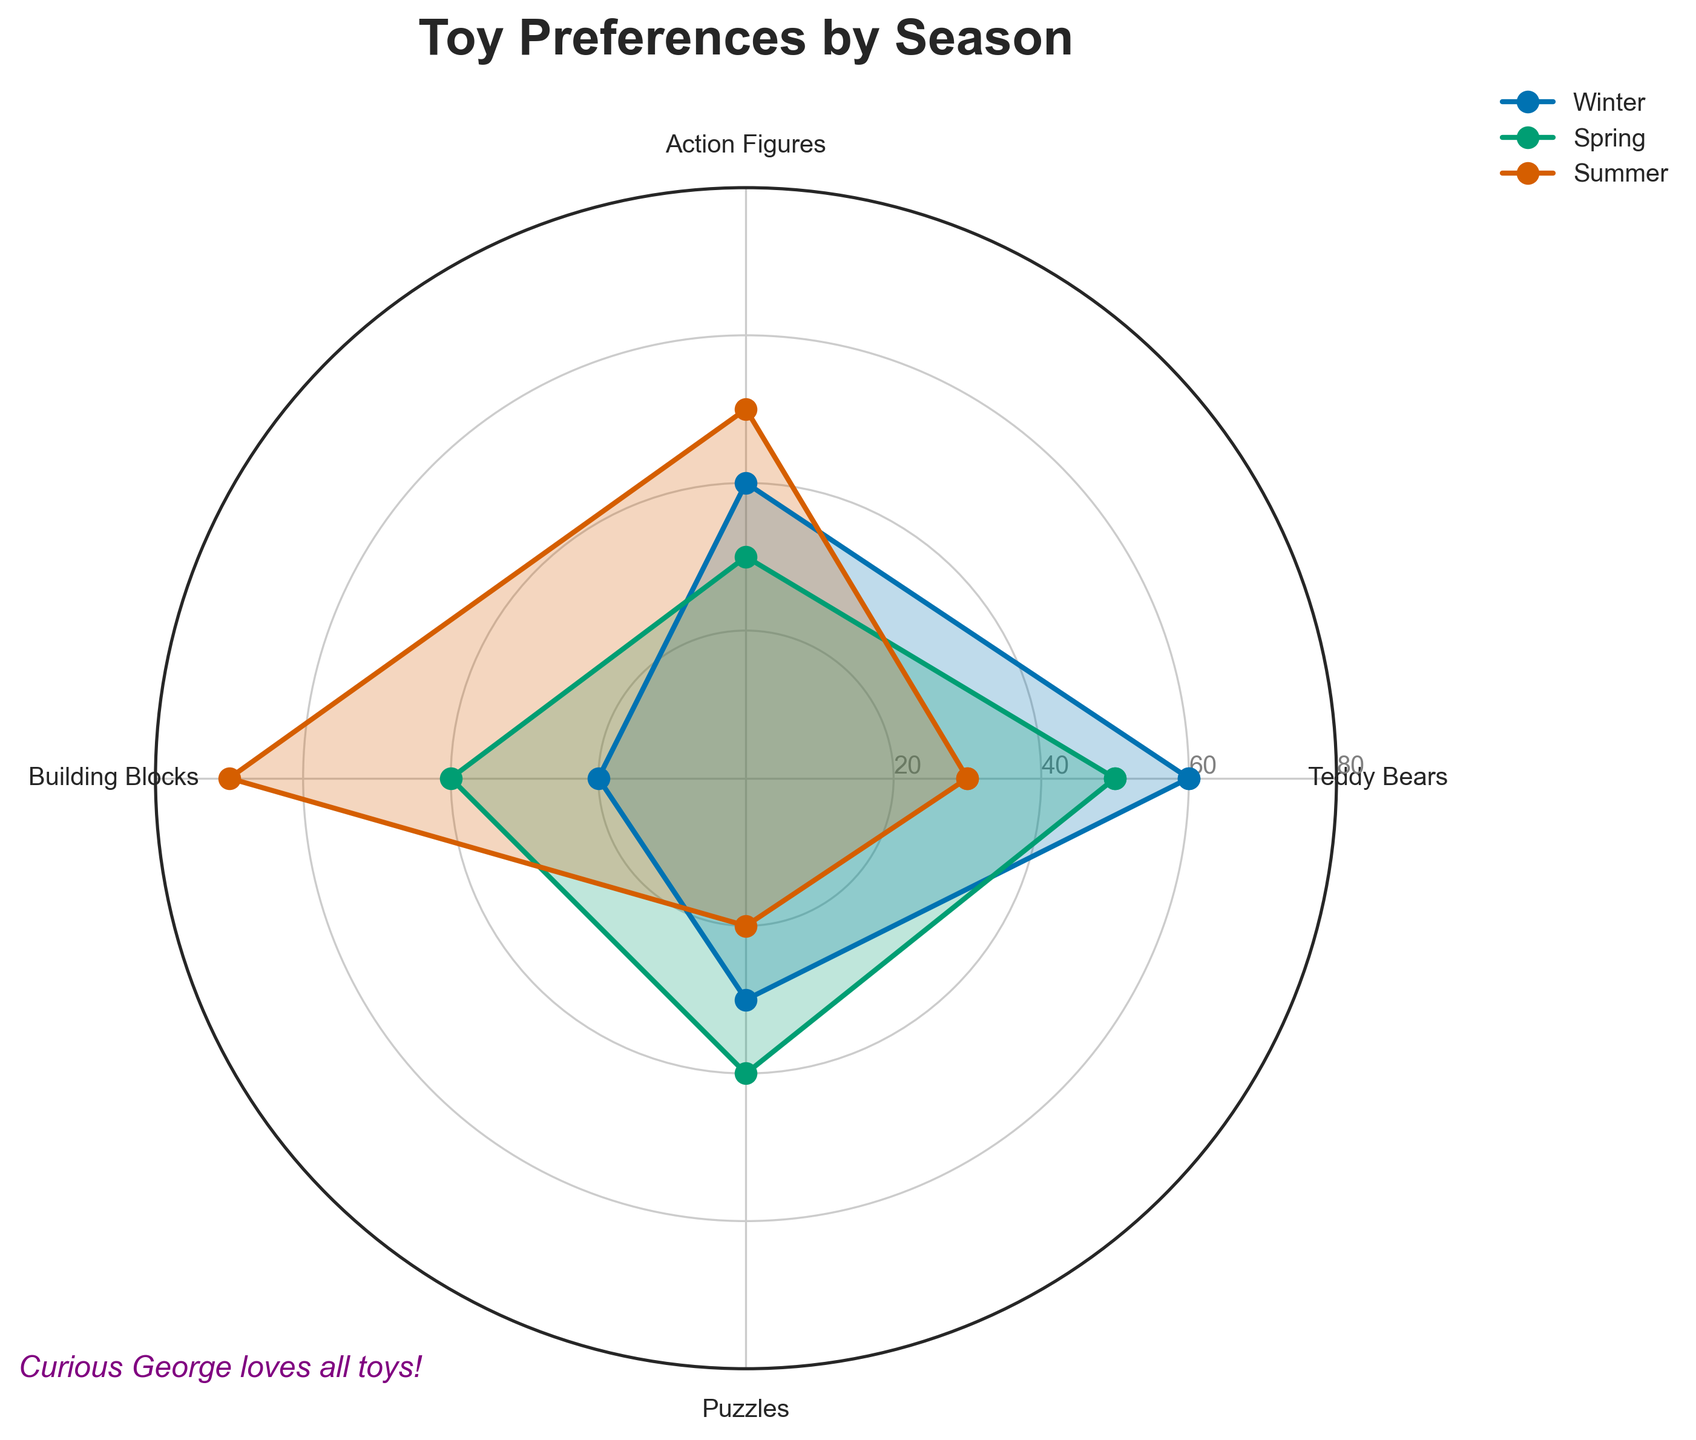What is the title of the radar chart? The title is prominently displayed at the top of the chart.
Answer: Toy Preferences by Season Which toy type is most favored during the Winter? Look at the values for each toy type during Winter and find the highest one. Teddy Bears has the highest value at 60.
Answer: Teddy Bears During which season are Action Figures most preferred? Compare the values for Action Figures across different seasons. The highest value, 60, is found in Autumn.
Answer: Autumn How does the preference for Building Blocks change from Spring to Summer? Compare the values for Building Blocks in Spring (40) and Summer (70). The preference increases from 40 to 70.
Answer: It increases Which season has the highest preference for Puzzles? Look at the values for Puzzles in all seasons. The highest value, 40, is in Spring.
Answer: Spring Rank the seasons from highest to lowest preference for Teddy Bears. Compare the Teddy Bears values across all seasons: Winter (60), Spring (50), Autumn (40), Summer (30). Sort them in descending order.
Answer: Winter, Spring, Autumn, Summer What is the average preference for Action Figures across Winter and Summer? Add the values for Action Figures in Winter (40) and Summer (50) and then divide by 2. (40 + 50) / 2 = 45
Answer: 45 Is the preference for Puzzles equal in any two seasons? Compare the values for Puzzles across different seasons. Winter (30), Spring (40), Summer (20), Autumn (30). Winter and Autumn both have a value of 30.
Answer: Yes, Winter and Autumn Which toy type has the most stable preference across the seasons? Examine the range of values for each toy type. Puzzles vary from 20 to 40. Building Blocks range from 30 to 70. Teddy Bears range from 30 to 60. Action Figures range from 30 to 60. The smallest range belongs to Puzzles.
Answer: Puzzles Comparing Winter and Spring, which toy type sees the greatest decrease in preference? Calculate the difference for each toy type from Winter to Spring. Teddy Bears: 60 to 50 (-10), Action Figures: 40 to 30 (-10), Building Blocks: 20 to 40 (+20), Puzzles: 30 to 40 (+10). The greatest decrease is Action Figures and Teddy Bears (-10).
Answer: Teddy Bears and Action Figures 